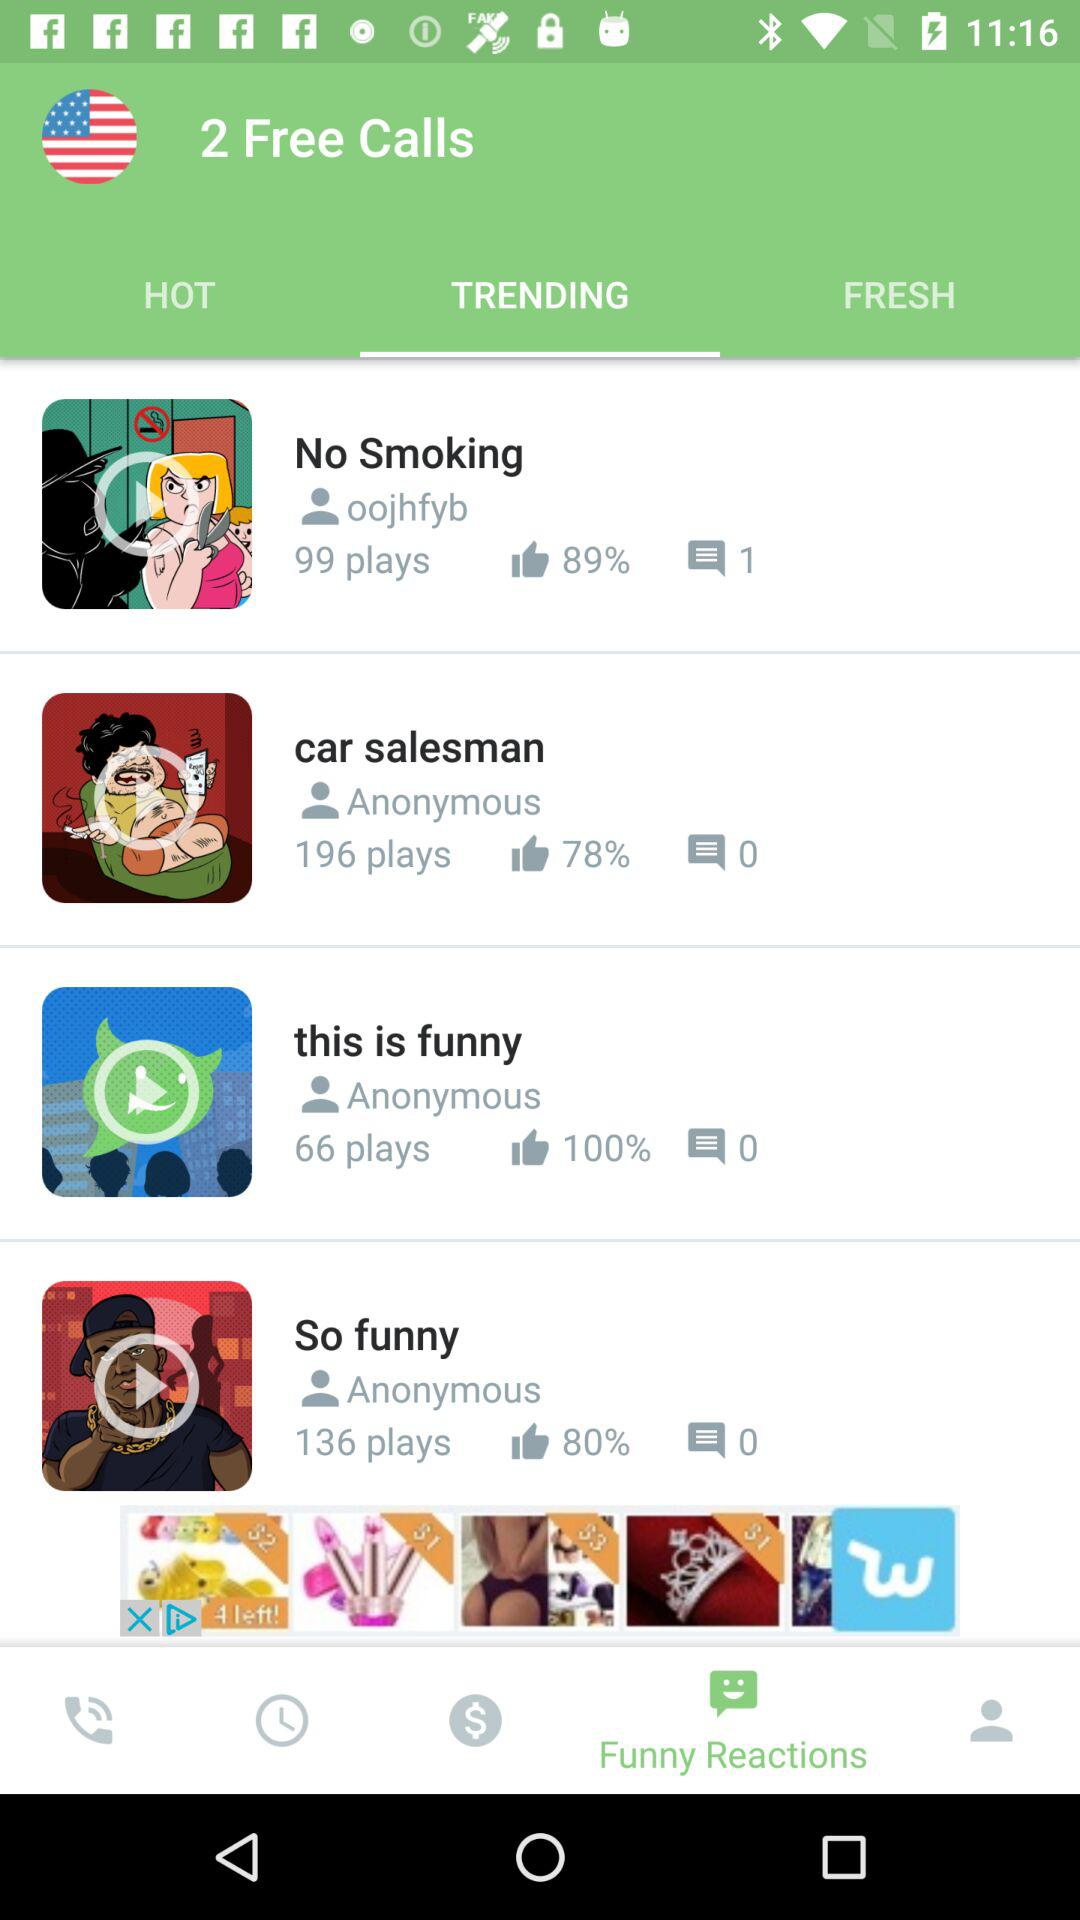How many comments are there of the "No Smoking" video? There is 1 comment. 